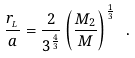Convert formula to latex. <formula><loc_0><loc_0><loc_500><loc_500>\frac { r _ { _ { L } } } { a } = \frac { 2 } { 3 ^ { \frac { 4 } { 3 } } } \left ( \frac { M _ { 2 } } { M } \right ) ^ { \frac { 1 } { 3 } } \ .</formula> 